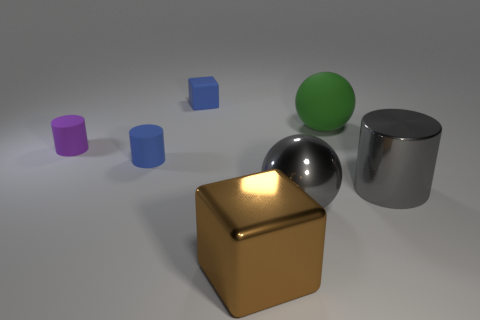Which object stands out the most in this image, and why? The golden cube stands out most due to its prominent position in the foreground, its lustrous finish, and the way it captures the light, drawing the viewer's eye with its bright highlights and stark contrast with the more muted tones of the other objects. 